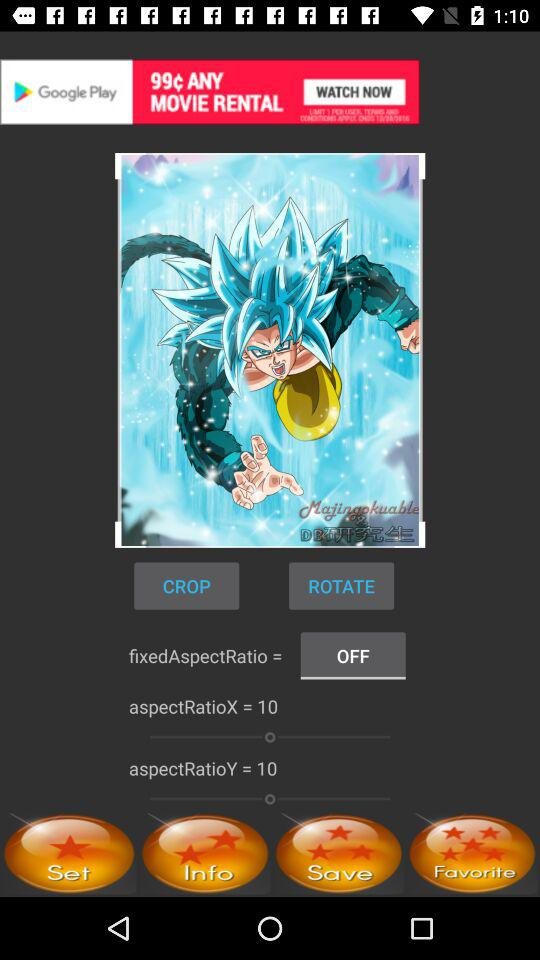What is the status of the "fixedAspectRatio"? The status is "off". 